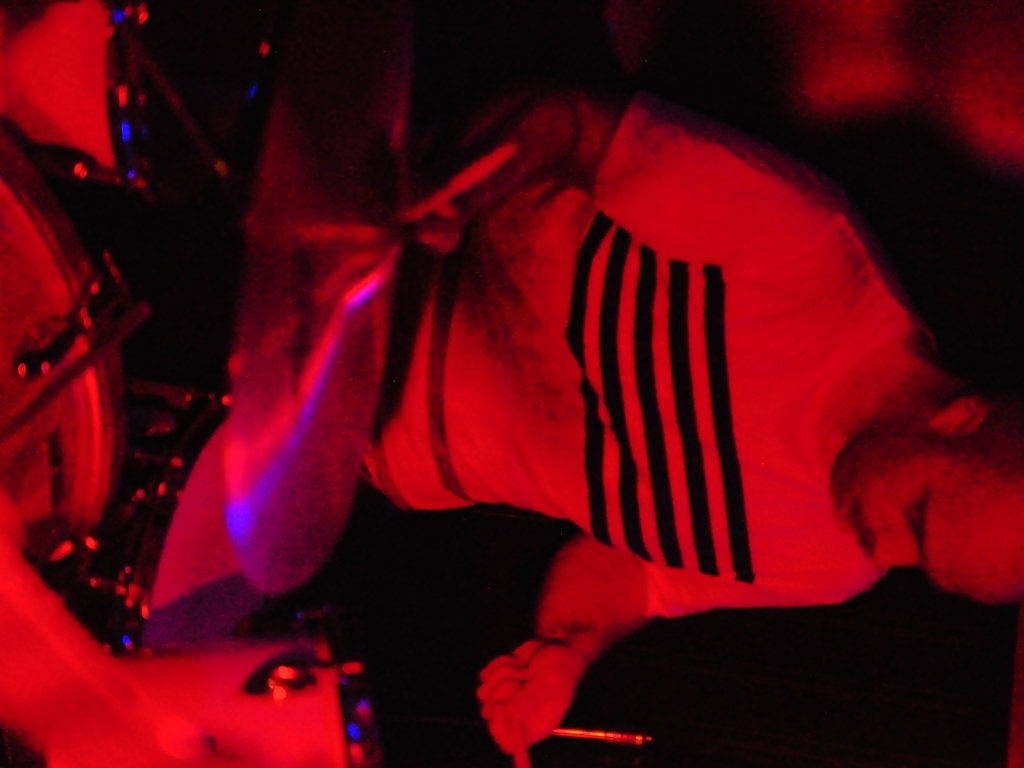Is the main subject of the image blurry? Yes, the main subject appears to be blurred, likely due to motion and the lighting conditions, which can suggest an action shot, perhaps captured during a live performance or dynamic activity. 